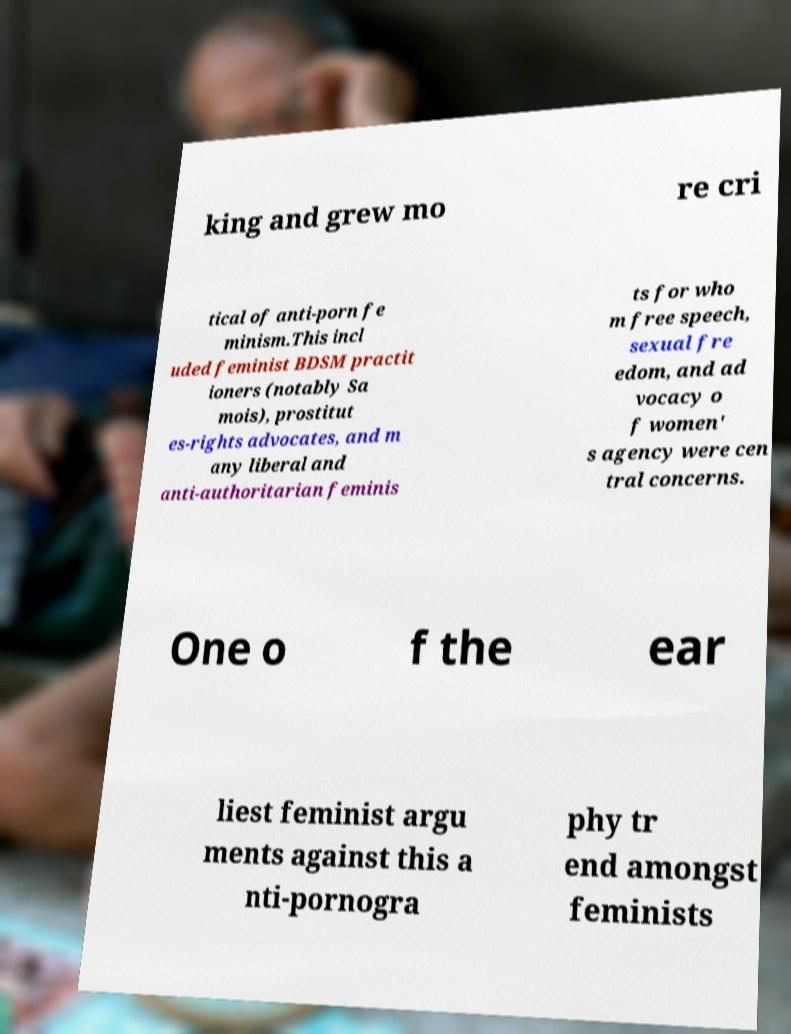Could you assist in decoding the text presented in this image and type it out clearly? king and grew mo re cri tical of anti-porn fe minism.This incl uded feminist BDSM practit ioners (notably Sa mois), prostitut es-rights advocates, and m any liberal and anti-authoritarian feminis ts for who m free speech, sexual fre edom, and ad vocacy o f women' s agency were cen tral concerns. One o f the ear liest feminist argu ments against this a nti-pornogra phy tr end amongst feminists 